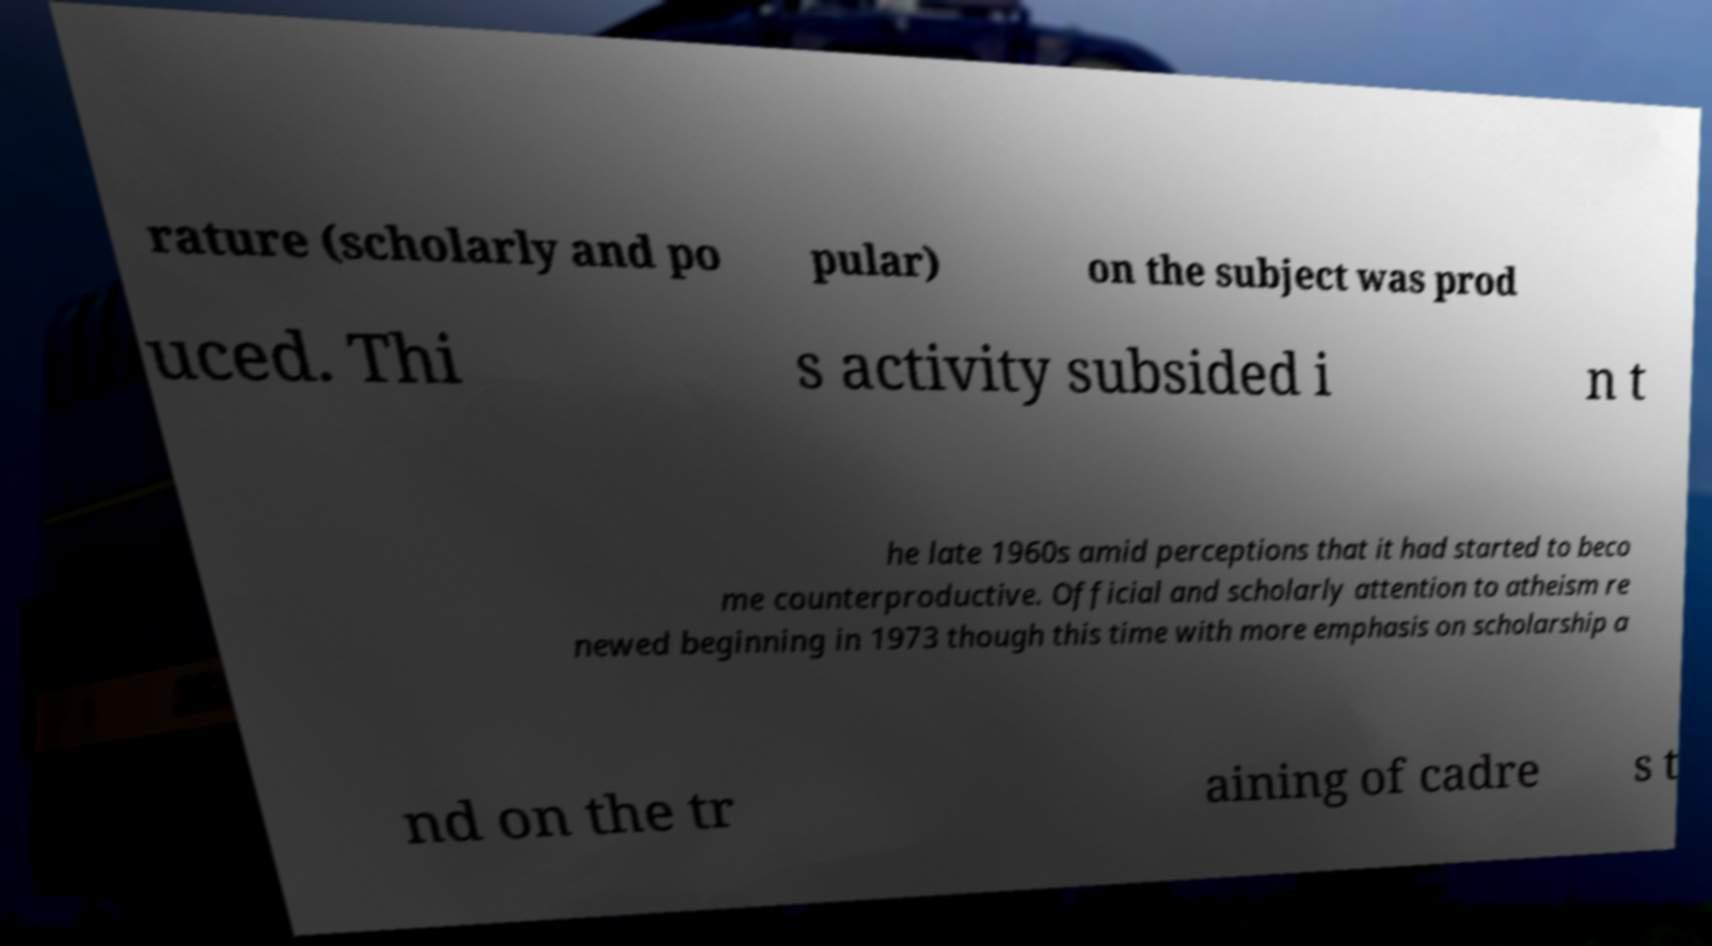Could you assist in decoding the text presented in this image and type it out clearly? rature (scholarly and po pular) on the subject was prod uced. Thi s activity subsided i n t he late 1960s amid perceptions that it had started to beco me counterproductive. Official and scholarly attention to atheism re newed beginning in 1973 though this time with more emphasis on scholarship a nd on the tr aining of cadre s t 